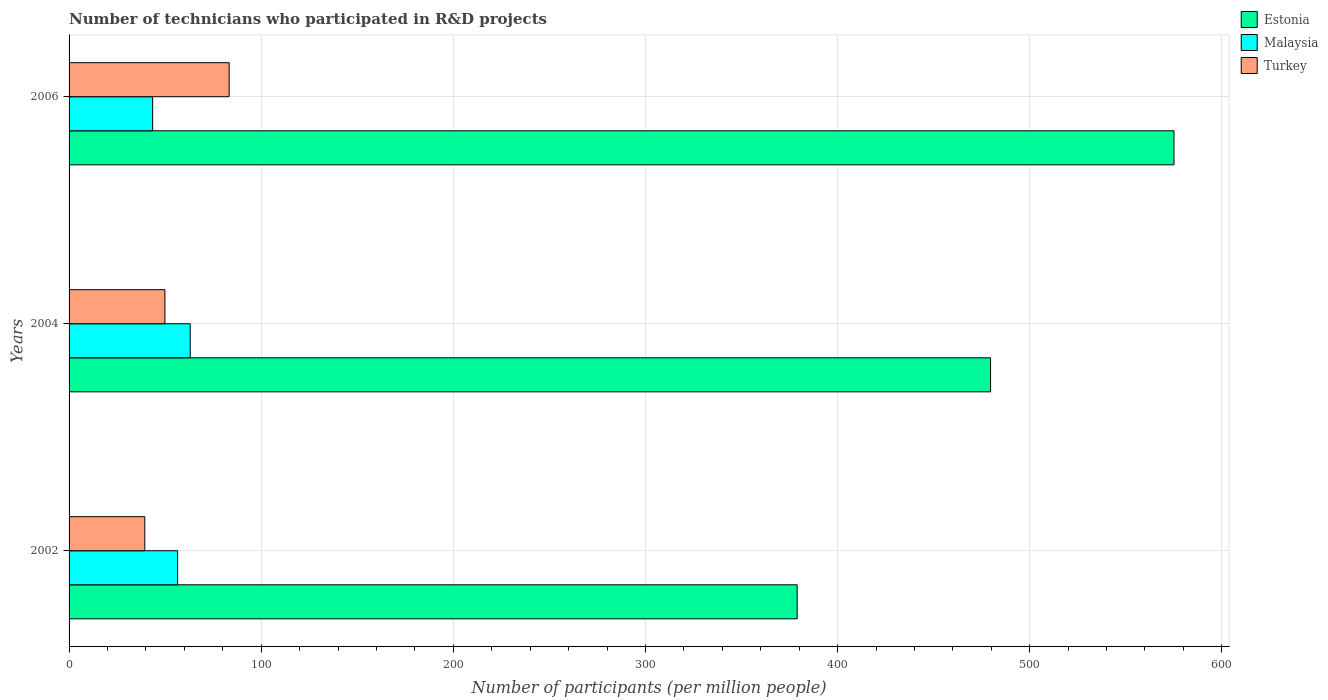How many groups of bars are there?
Your answer should be compact. 3. Are the number of bars on each tick of the Y-axis equal?
Keep it short and to the point. Yes. How many bars are there on the 2nd tick from the bottom?
Give a very brief answer. 3. What is the label of the 3rd group of bars from the top?
Your answer should be very brief. 2002. In how many cases, is the number of bars for a given year not equal to the number of legend labels?
Keep it short and to the point. 0. What is the number of technicians who participated in R&D projects in Turkey in 2002?
Ensure brevity in your answer.  39.42. Across all years, what is the maximum number of technicians who participated in R&D projects in Estonia?
Provide a succinct answer. 575.08. Across all years, what is the minimum number of technicians who participated in R&D projects in Malaysia?
Your response must be concise. 43.5. In which year was the number of technicians who participated in R&D projects in Malaysia minimum?
Keep it short and to the point. 2006. What is the total number of technicians who participated in R&D projects in Turkey in the graph?
Your answer should be very brief. 172.63. What is the difference between the number of technicians who participated in R&D projects in Malaysia in 2004 and that in 2006?
Provide a succinct answer. 19.58. What is the difference between the number of technicians who participated in R&D projects in Malaysia in 2004 and the number of technicians who participated in R&D projects in Estonia in 2006?
Offer a terse response. -512.01. What is the average number of technicians who participated in R&D projects in Malaysia per year?
Ensure brevity in your answer.  54.36. In the year 2004, what is the difference between the number of technicians who participated in R&D projects in Estonia and number of technicians who participated in R&D projects in Turkey?
Your answer should be compact. 429.74. What is the ratio of the number of technicians who participated in R&D projects in Estonia in 2002 to that in 2006?
Your response must be concise. 0.66. Is the number of technicians who participated in R&D projects in Turkey in 2002 less than that in 2006?
Make the answer very short. Yes. Is the difference between the number of technicians who participated in R&D projects in Estonia in 2002 and 2004 greater than the difference between the number of technicians who participated in R&D projects in Turkey in 2002 and 2004?
Give a very brief answer. No. What is the difference between the highest and the second highest number of technicians who participated in R&D projects in Malaysia?
Provide a succinct answer. 6.56. What is the difference between the highest and the lowest number of technicians who participated in R&D projects in Malaysia?
Your answer should be very brief. 19.58. In how many years, is the number of technicians who participated in R&D projects in Turkey greater than the average number of technicians who participated in R&D projects in Turkey taken over all years?
Give a very brief answer. 1. Is the sum of the number of technicians who participated in R&D projects in Estonia in 2004 and 2006 greater than the maximum number of technicians who participated in R&D projects in Malaysia across all years?
Ensure brevity in your answer.  Yes. What does the 3rd bar from the top in 2004 represents?
Keep it short and to the point. Estonia. What does the 1st bar from the bottom in 2006 represents?
Your answer should be compact. Estonia. Is it the case that in every year, the sum of the number of technicians who participated in R&D projects in Malaysia and number of technicians who participated in R&D projects in Turkey is greater than the number of technicians who participated in R&D projects in Estonia?
Keep it short and to the point. No. Are the values on the major ticks of X-axis written in scientific E-notation?
Your answer should be very brief. No. Does the graph contain any zero values?
Give a very brief answer. No. Does the graph contain grids?
Offer a terse response. Yes. Where does the legend appear in the graph?
Your answer should be compact. Top right. How many legend labels are there?
Your response must be concise. 3. What is the title of the graph?
Give a very brief answer. Number of technicians who participated in R&D projects. Does "Zambia" appear as one of the legend labels in the graph?
Give a very brief answer. No. What is the label or title of the X-axis?
Provide a succinct answer. Number of participants (per million people). What is the Number of participants (per million people) in Estonia in 2002?
Give a very brief answer. 378.96. What is the Number of participants (per million people) of Malaysia in 2002?
Provide a short and direct response. 56.51. What is the Number of participants (per million people) of Turkey in 2002?
Ensure brevity in your answer.  39.42. What is the Number of participants (per million people) of Estonia in 2004?
Provide a succinct answer. 479.63. What is the Number of participants (per million people) in Malaysia in 2004?
Your answer should be very brief. 63.07. What is the Number of participants (per million people) of Turkey in 2004?
Your answer should be compact. 49.89. What is the Number of participants (per million people) of Estonia in 2006?
Offer a very short reply. 575.08. What is the Number of participants (per million people) in Malaysia in 2006?
Provide a succinct answer. 43.5. What is the Number of participants (per million people) in Turkey in 2006?
Provide a succinct answer. 83.32. Across all years, what is the maximum Number of participants (per million people) of Estonia?
Your answer should be compact. 575.08. Across all years, what is the maximum Number of participants (per million people) of Malaysia?
Make the answer very short. 63.07. Across all years, what is the maximum Number of participants (per million people) in Turkey?
Give a very brief answer. 83.32. Across all years, what is the minimum Number of participants (per million people) in Estonia?
Keep it short and to the point. 378.96. Across all years, what is the minimum Number of participants (per million people) in Malaysia?
Keep it short and to the point. 43.5. Across all years, what is the minimum Number of participants (per million people) in Turkey?
Provide a succinct answer. 39.42. What is the total Number of participants (per million people) in Estonia in the graph?
Keep it short and to the point. 1433.67. What is the total Number of participants (per million people) of Malaysia in the graph?
Give a very brief answer. 163.08. What is the total Number of participants (per million people) of Turkey in the graph?
Offer a very short reply. 172.63. What is the difference between the Number of participants (per million people) in Estonia in 2002 and that in 2004?
Make the answer very short. -100.67. What is the difference between the Number of participants (per million people) of Malaysia in 2002 and that in 2004?
Provide a short and direct response. -6.56. What is the difference between the Number of participants (per million people) of Turkey in 2002 and that in 2004?
Give a very brief answer. -10.47. What is the difference between the Number of participants (per million people) in Estonia in 2002 and that in 2006?
Offer a very short reply. -196.12. What is the difference between the Number of participants (per million people) in Malaysia in 2002 and that in 2006?
Offer a very short reply. 13.01. What is the difference between the Number of participants (per million people) of Turkey in 2002 and that in 2006?
Your answer should be very brief. -43.9. What is the difference between the Number of participants (per million people) in Estonia in 2004 and that in 2006?
Offer a very short reply. -95.45. What is the difference between the Number of participants (per million people) of Malaysia in 2004 and that in 2006?
Give a very brief answer. 19.58. What is the difference between the Number of participants (per million people) in Turkey in 2004 and that in 2006?
Offer a very short reply. -33.43. What is the difference between the Number of participants (per million people) of Estonia in 2002 and the Number of participants (per million people) of Malaysia in 2004?
Make the answer very short. 315.88. What is the difference between the Number of participants (per million people) of Estonia in 2002 and the Number of participants (per million people) of Turkey in 2004?
Your response must be concise. 329.07. What is the difference between the Number of participants (per million people) of Malaysia in 2002 and the Number of participants (per million people) of Turkey in 2004?
Ensure brevity in your answer.  6.62. What is the difference between the Number of participants (per million people) of Estonia in 2002 and the Number of participants (per million people) of Malaysia in 2006?
Make the answer very short. 335.46. What is the difference between the Number of participants (per million people) in Estonia in 2002 and the Number of participants (per million people) in Turkey in 2006?
Ensure brevity in your answer.  295.64. What is the difference between the Number of participants (per million people) of Malaysia in 2002 and the Number of participants (per million people) of Turkey in 2006?
Provide a succinct answer. -26.81. What is the difference between the Number of participants (per million people) of Estonia in 2004 and the Number of participants (per million people) of Malaysia in 2006?
Provide a short and direct response. 436.13. What is the difference between the Number of participants (per million people) of Estonia in 2004 and the Number of participants (per million people) of Turkey in 2006?
Offer a terse response. 396.31. What is the difference between the Number of participants (per million people) of Malaysia in 2004 and the Number of participants (per million people) of Turkey in 2006?
Provide a short and direct response. -20.25. What is the average Number of participants (per million people) of Estonia per year?
Keep it short and to the point. 477.89. What is the average Number of participants (per million people) in Malaysia per year?
Keep it short and to the point. 54.36. What is the average Number of participants (per million people) in Turkey per year?
Offer a very short reply. 57.54. In the year 2002, what is the difference between the Number of participants (per million people) in Estonia and Number of participants (per million people) in Malaysia?
Offer a terse response. 322.45. In the year 2002, what is the difference between the Number of participants (per million people) in Estonia and Number of participants (per million people) in Turkey?
Your response must be concise. 339.54. In the year 2002, what is the difference between the Number of participants (per million people) of Malaysia and Number of participants (per million people) of Turkey?
Your response must be concise. 17.1. In the year 2004, what is the difference between the Number of participants (per million people) in Estonia and Number of participants (per million people) in Malaysia?
Provide a short and direct response. 416.56. In the year 2004, what is the difference between the Number of participants (per million people) of Estonia and Number of participants (per million people) of Turkey?
Offer a very short reply. 429.74. In the year 2004, what is the difference between the Number of participants (per million people) of Malaysia and Number of participants (per million people) of Turkey?
Your answer should be very brief. 13.18. In the year 2006, what is the difference between the Number of participants (per million people) in Estonia and Number of participants (per million people) in Malaysia?
Your answer should be very brief. 531.59. In the year 2006, what is the difference between the Number of participants (per million people) of Estonia and Number of participants (per million people) of Turkey?
Provide a short and direct response. 491.76. In the year 2006, what is the difference between the Number of participants (per million people) of Malaysia and Number of participants (per million people) of Turkey?
Keep it short and to the point. -39.82. What is the ratio of the Number of participants (per million people) of Estonia in 2002 to that in 2004?
Provide a succinct answer. 0.79. What is the ratio of the Number of participants (per million people) in Malaysia in 2002 to that in 2004?
Provide a short and direct response. 0.9. What is the ratio of the Number of participants (per million people) in Turkey in 2002 to that in 2004?
Make the answer very short. 0.79. What is the ratio of the Number of participants (per million people) in Estonia in 2002 to that in 2006?
Your answer should be compact. 0.66. What is the ratio of the Number of participants (per million people) in Malaysia in 2002 to that in 2006?
Keep it short and to the point. 1.3. What is the ratio of the Number of participants (per million people) in Turkey in 2002 to that in 2006?
Provide a short and direct response. 0.47. What is the ratio of the Number of participants (per million people) of Estonia in 2004 to that in 2006?
Your answer should be very brief. 0.83. What is the ratio of the Number of participants (per million people) of Malaysia in 2004 to that in 2006?
Offer a terse response. 1.45. What is the ratio of the Number of participants (per million people) in Turkey in 2004 to that in 2006?
Offer a terse response. 0.6. What is the difference between the highest and the second highest Number of participants (per million people) in Estonia?
Your answer should be very brief. 95.45. What is the difference between the highest and the second highest Number of participants (per million people) in Malaysia?
Give a very brief answer. 6.56. What is the difference between the highest and the second highest Number of participants (per million people) of Turkey?
Your answer should be very brief. 33.43. What is the difference between the highest and the lowest Number of participants (per million people) in Estonia?
Your answer should be compact. 196.12. What is the difference between the highest and the lowest Number of participants (per million people) in Malaysia?
Give a very brief answer. 19.58. What is the difference between the highest and the lowest Number of participants (per million people) in Turkey?
Offer a terse response. 43.9. 